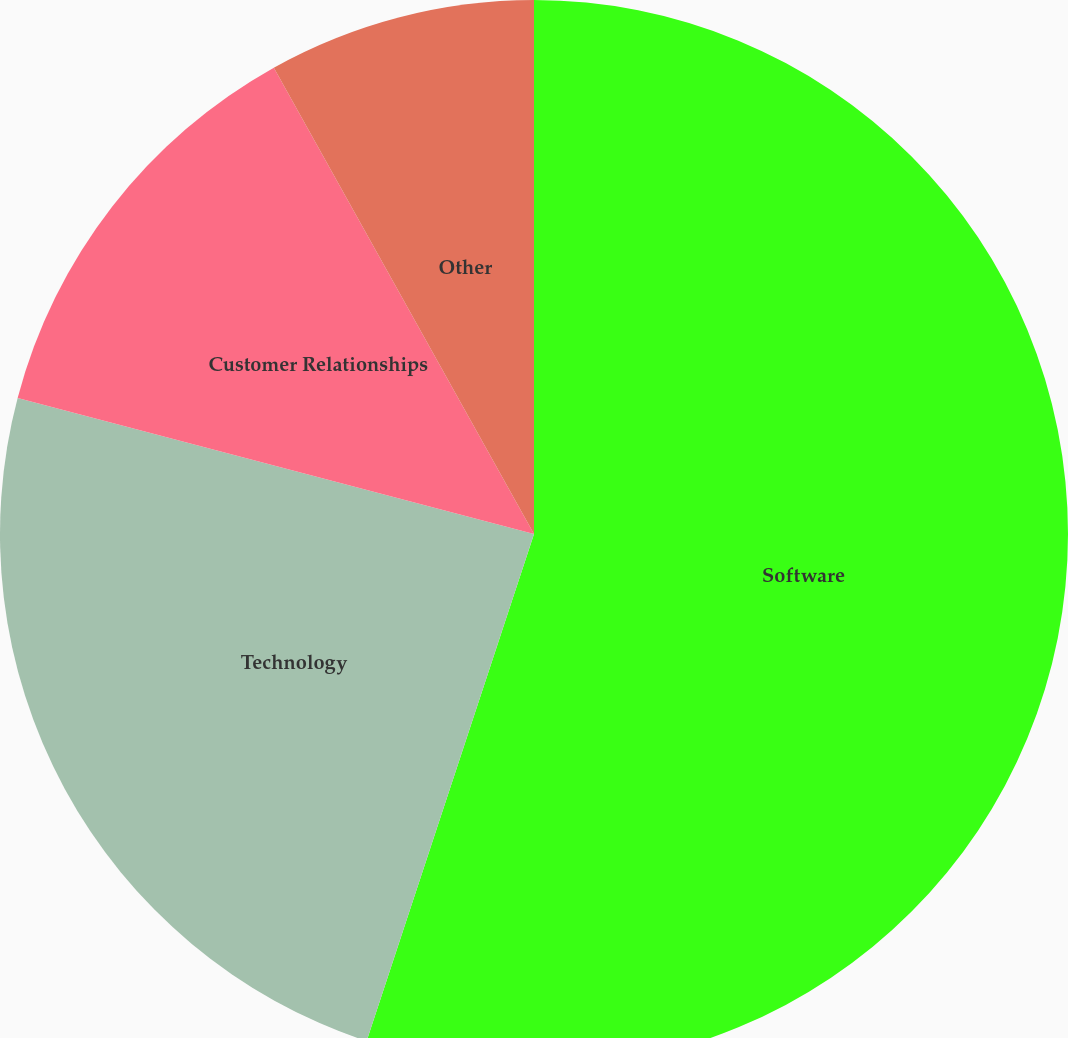<chart> <loc_0><loc_0><loc_500><loc_500><pie_chart><fcel>Software<fcel>Technology<fcel>Customer Relationships<fcel>Other<nl><fcel>55.08%<fcel>24.03%<fcel>12.8%<fcel>8.1%<nl></chart> 